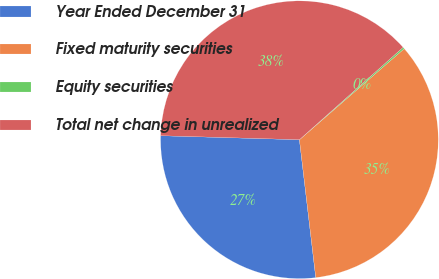<chart> <loc_0><loc_0><loc_500><loc_500><pie_chart><fcel>Year Ended December 31<fcel>Fixed maturity securities<fcel>Equity securities<fcel>Total net change in unrealized<nl><fcel>27.34%<fcel>34.51%<fcel>0.2%<fcel>37.96%<nl></chart> 